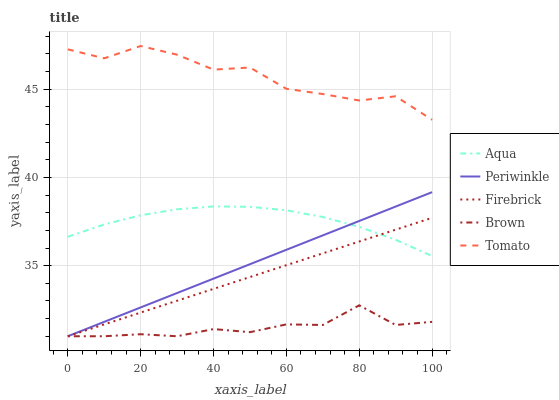Does Periwinkle have the minimum area under the curve?
Answer yes or no. No. Does Periwinkle have the maximum area under the curve?
Answer yes or no. No. Is Periwinkle the smoothest?
Answer yes or no. No. Is Periwinkle the roughest?
Answer yes or no. No. Does Aqua have the lowest value?
Answer yes or no. No. Does Periwinkle have the highest value?
Answer yes or no. No. Is Firebrick less than Tomato?
Answer yes or no. Yes. Is Aqua greater than Brown?
Answer yes or no. Yes. Does Firebrick intersect Tomato?
Answer yes or no. No. 